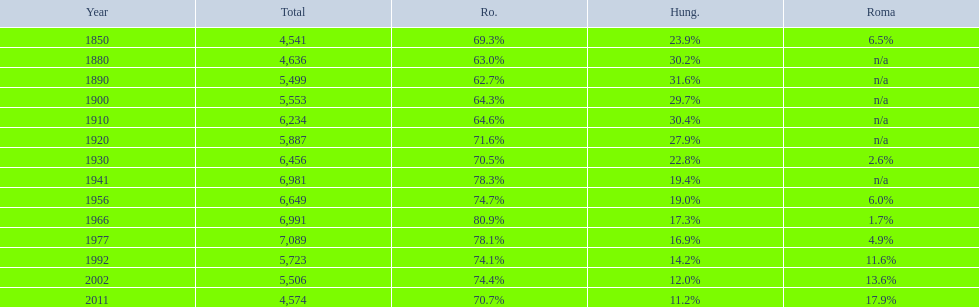Which year is previous to the year that had 74.1% in romanian population? 1977. 